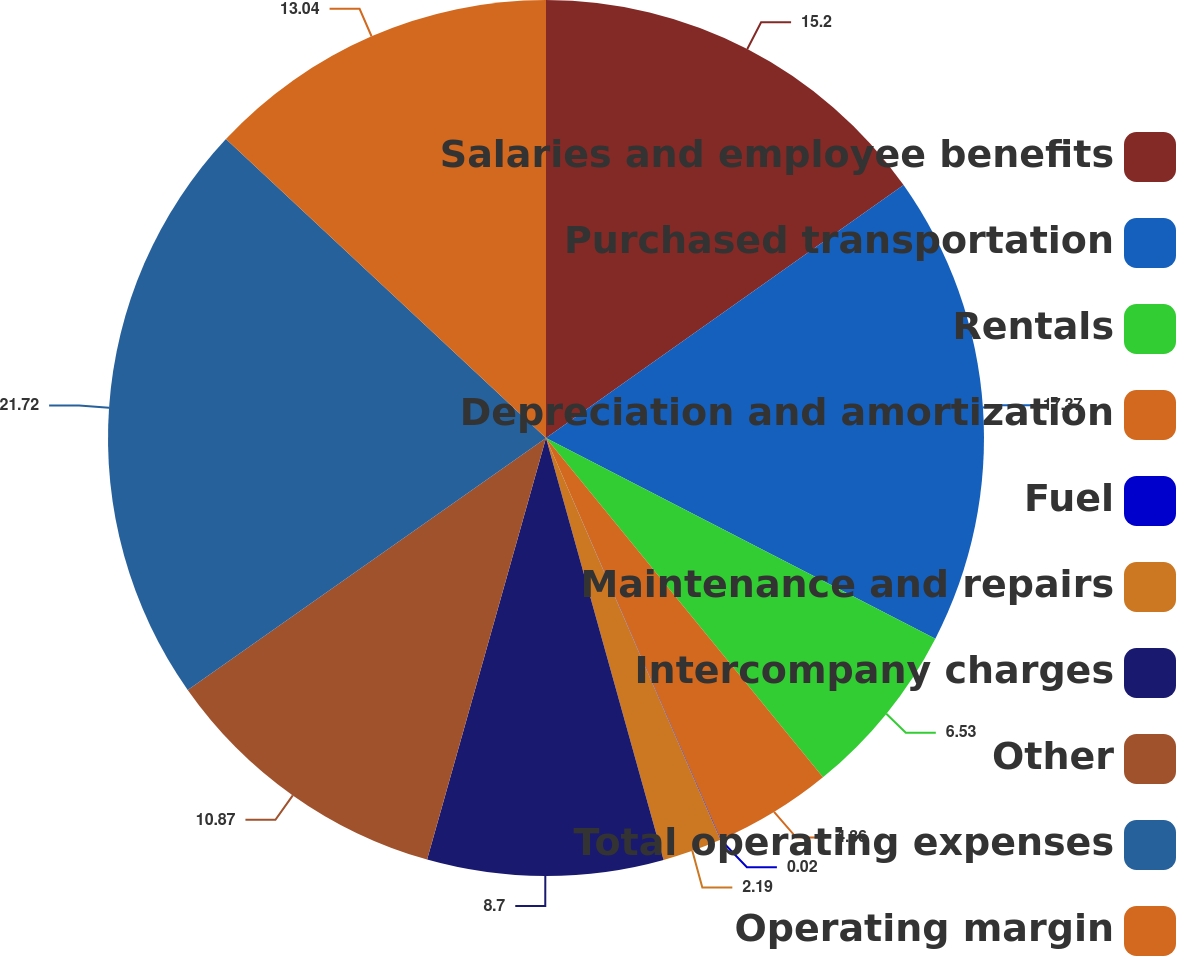Convert chart to OTSL. <chart><loc_0><loc_0><loc_500><loc_500><pie_chart><fcel>Salaries and employee benefits<fcel>Purchased transportation<fcel>Rentals<fcel>Depreciation and amortization<fcel>Fuel<fcel>Maintenance and repairs<fcel>Intercompany charges<fcel>Other<fcel>Total operating expenses<fcel>Operating margin<nl><fcel>15.2%<fcel>17.37%<fcel>6.53%<fcel>4.36%<fcel>0.02%<fcel>2.19%<fcel>8.7%<fcel>10.87%<fcel>21.71%<fcel>13.04%<nl></chart> 